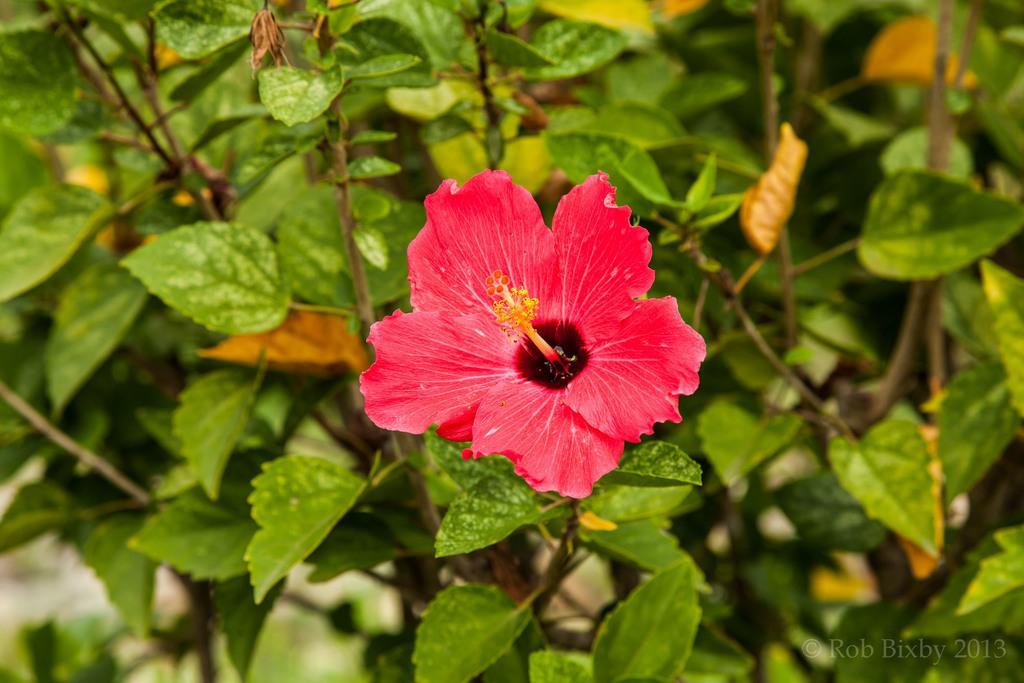Can you describe this image briefly? The picture consists of a plant. In the center of the picture there is a red color flower. 